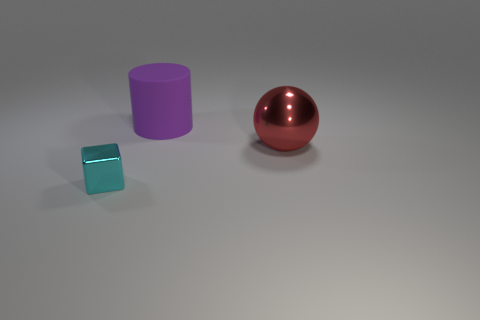Add 2 purple matte balls. How many objects exist? 5 Subtract all cylinders. How many objects are left? 2 Add 1 big matte cylinders. How many big matte cylinders are left? 2 Add 1 large purple things. How many large purple things exist? 2 Subtract 0 yellow cubes. How many objects are left? 3 Subtract all purple things. Subtract all big red spheres. How many objects are left? 1 